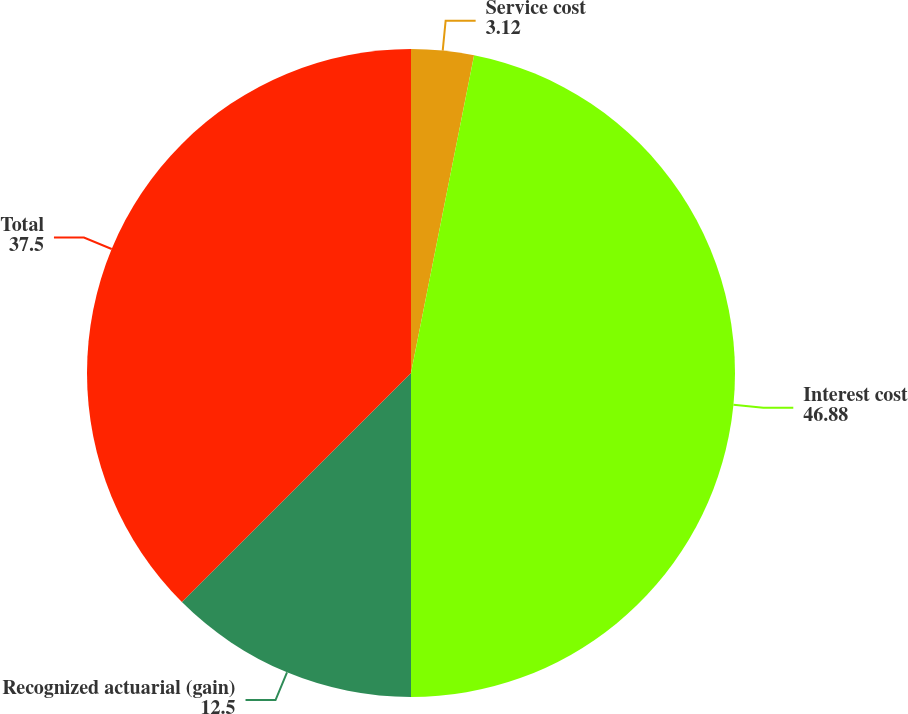Convert chart. <chart><loc_0><loc_0><loc_500><loc_500><pie_chart><fcel>Service cost<fcel>Interest cost<fcel>Recognized actuarial (gain)<fcel>Total<nl><fcel>3.12%<fcel>46.88%<fcel>12.5%<fcel>37.5%<nl></chart> 